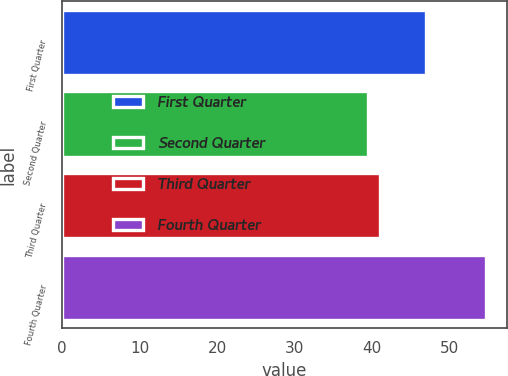<chart> <loc_0><loc_0><loc_500><loc_500><bar_chart><fcel>First Quarter<fcel>Second Quarter<fcel>Third Quarter<fcel>Fourth Quarter<nl><fcel>46.94<fcel>39.5<fcel>41.07<fcel>54.64<nl></chart> 